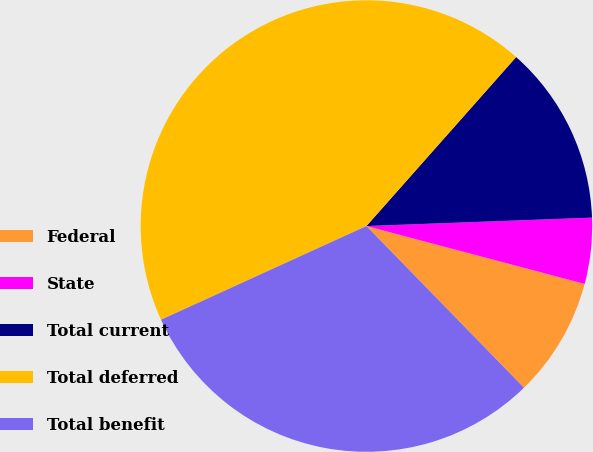<chart> <loc_0><loc_0><loc_500><loc_500><pie_chart><fcel>Federal<fcel>State<fcel>Total current<fcel>Total deferred<fcel>Total benefit<nl><fcel>8.58%<fcel>4.72%<fcel>12.87%<fcel>43.35%<fcel>30.48%<nl></chart> 